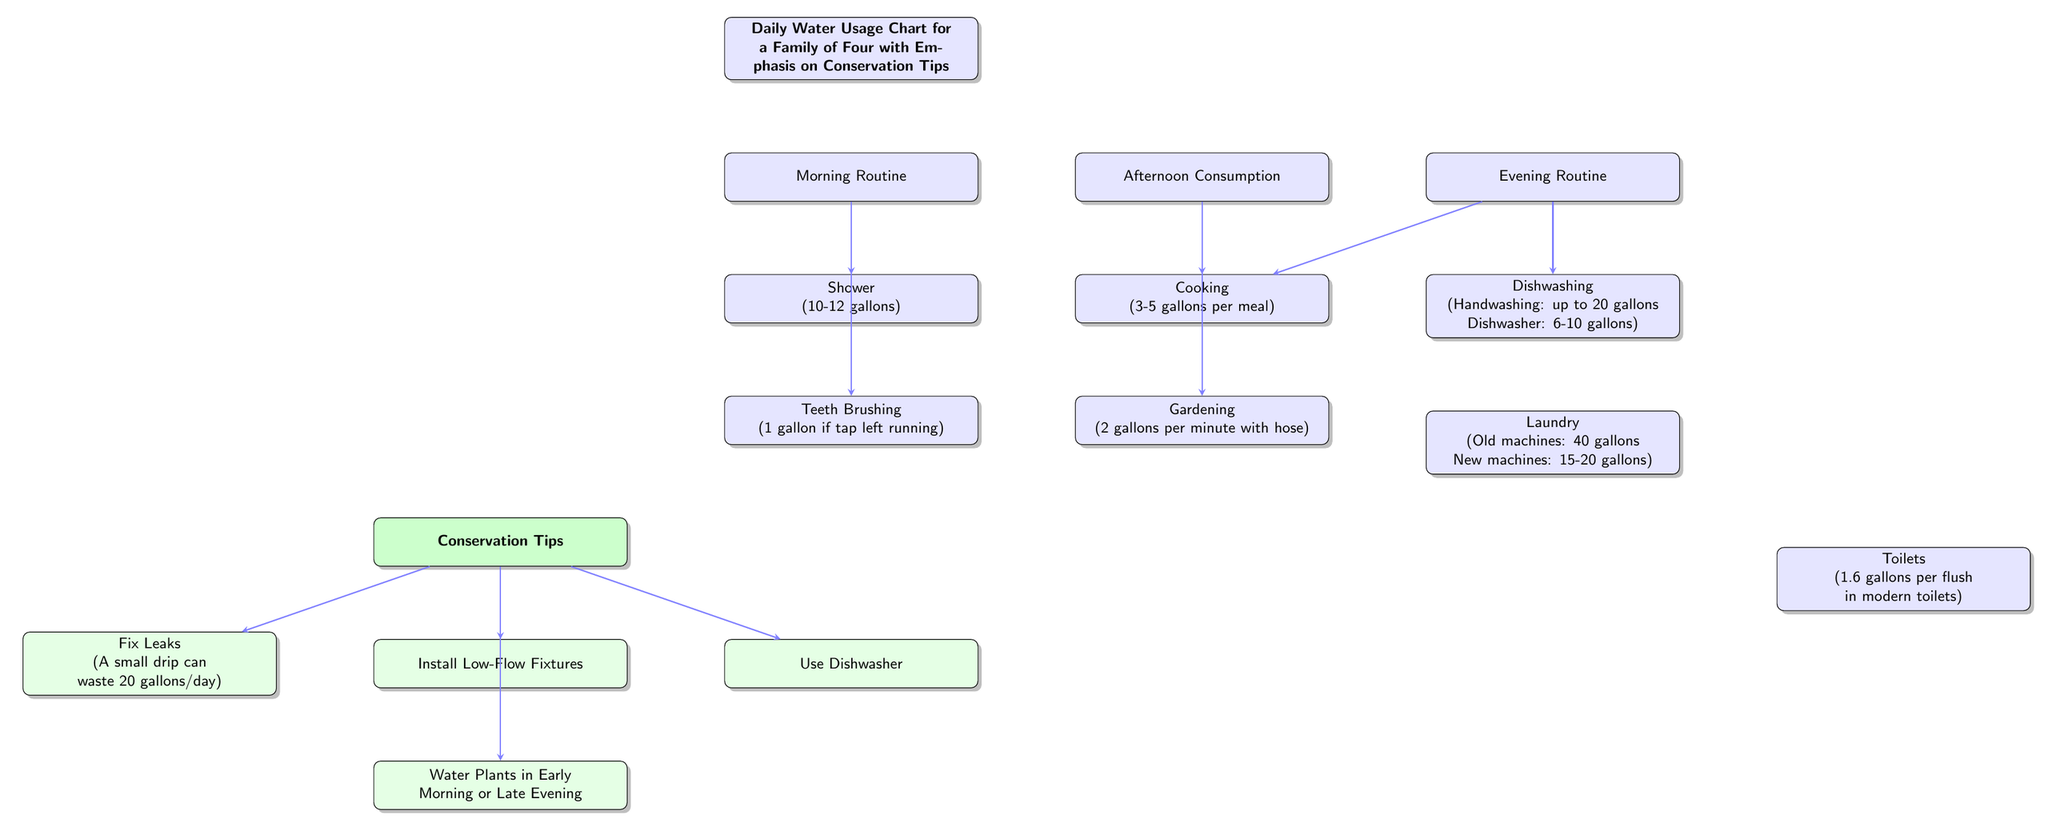what is the total water usage for a shower? The node related to shower indicates a usage of 10-12 gallons. Thus, the total water usage can be inferred as falling within this range.
Answer: 10-12 gallons how many gallons does brushing teeth waste if left running? According to the diagram, brushing teeth wastes 1 gallon if the tap is left running. The direct statement from the node provides this information.
Answer: 1 gallon which activity uses 3-5 gallons per meal? The cooking node specifies that cooking uses 3-5 gallons per meal. This information directly correlates with the description in the diagram.
Answer: Cooking what is a conservation tip related to fixing leaks? The conservation tip states, "Fix Leaks" and specifies that a small drip can waste 20 gallons a day. This clear guideline is presented in the diagram.
Answer: Fix Leaks which water usage activity is mentioned under the evening routine? The evening routine includes dishwashing and laundry as part of the activities, based on the nodes connected to this time frame.
Answer: Dishwashing and Laundry what are the two activities that use water in the afternoon? The nodes below the afternoon consumption include cooking and gardening, indicating these are the activities that utilize water in the afternoon.
Answer: Cooking and Gardening which conservation tip suggests watering plants in the morning? The conservation tip points to "Water Plants in Early Morning or Late Evening" indicating the preferred times to water plants.
Answer: Water Plants in Early Morning or Late Evening how much can old washing machines use? The laundry node specifies that old machines use 40 gallons, providing clear information about their water consumption in comparison to modern machines.
Answer: 40 gallons what is the water usage for modern toilets per flush? The toilet node notes that modern toilets use 1.6 gallons per flush, which gives straightforward information about this specific water usage.
Answer: 1.6 gallons per flush 